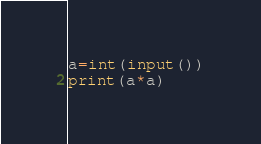Convert code to text. <code><loc_0><loc_0><loc_500><loc_500><_Python_>a=int(input())
print(a*a)
</code> 